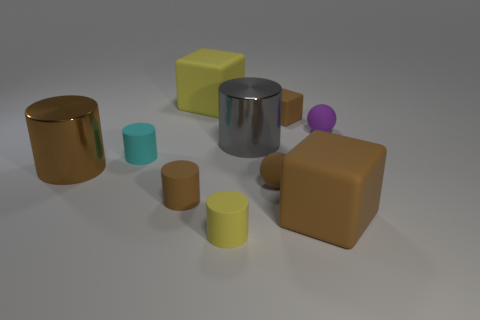The small matte block has what color?
Give a very brief answer. Brown. How many small things are gray metallic cylinders or red rubber cubes?
Ensure brevity in your answer.  0. Does the matte thing that is in front of the big brown matte thing have the same size as the thing right of the big brown rubber object?
Provide a succinct answer. Yes. The gray thing that is the same shape as the tiny yellow rubber object is what size?
Your response must be concise. Large. Is the number of rubber cubes in front of the purple rubber thing greater than the number of cyan cylinders behind the tiny cyan object?
Ensure brevity in your answer.  Yes. There is a brown thing that is left of the small brown ball and behind the brown sphere; what material is it?
Provide a short and direct response. Metal. What color is the other thing that is the same shape as the tiny purple matte object?
Keep it short and to the point. Brown. The purple object has what size?
Offer a terse response. Small. There is a large cube that is to the left of the brown cube that is in front of the brown matte cylinder; what color is it?
Make the answer very short. Yellow. How many large rubber cubes are to the right of the gray cylinder and behind the brown rubber sphere?
Provide a short and direct response. 0. 